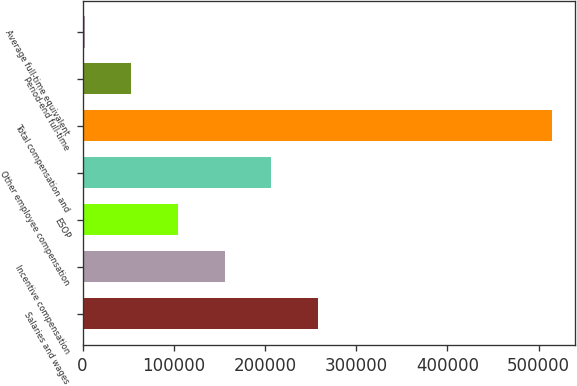Convert chart to OTSL. <chart><loc_0><loc_0><loc_500><loc_500><bar_chart><fcel>Salaries and wages<fcel>Incentive compensation<fcel>ESOP<fcel>Other employee compensation<fcel>Total compensation and<fcel>Period-end full-time<fcel>Average full-time equivalent<nl><fcel>258248<fcel>155838<fcel>104634<fcel>207043<fcel>514270<fcel>53429.5<fcel>2225<nl></chart> 